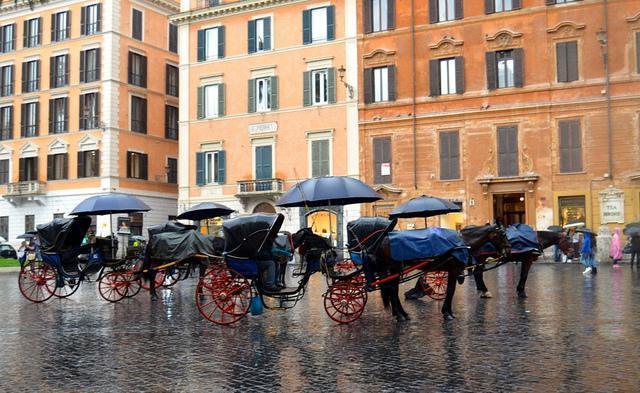What group usually uses this mode of transport?
Select the accurate answer and provide justification: `Answer: choice
Rationale: srationale.`
Options: Amish, paratroopers, army rangers, pilots. Answer: amish.
Rationale: The amish don't use cars or technology. 